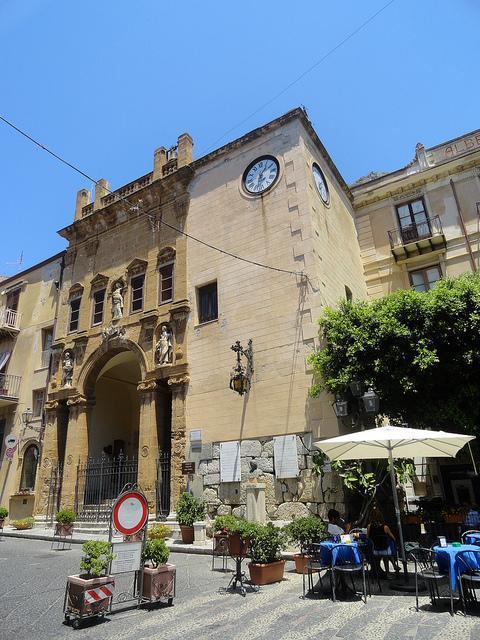How many clock faces?
Give a very brief answer. 2. How many potted plants are visible?
Give a very brief answer. 2. 